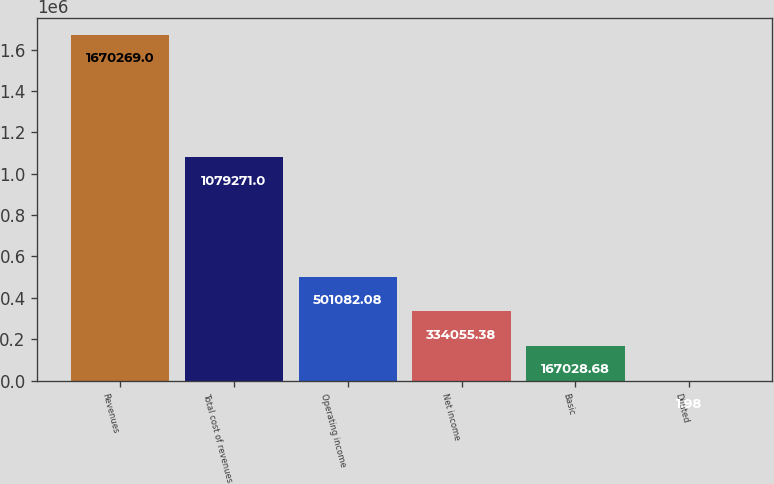Convert chart. <chart><loc_0><loc_0><loc_500><loc_500><bar_chart><fcel>Revenues<fcel>Total cost of revenues<fcel>Operating income<fcel>Net income<fcel>Basic<fcel>Diluted<nl><fcel>1.67027e+06<fcel>1.07927e+06<fcel>501082<fcel>334055<fcel>167029<fcel>1.98<nl></chart> 